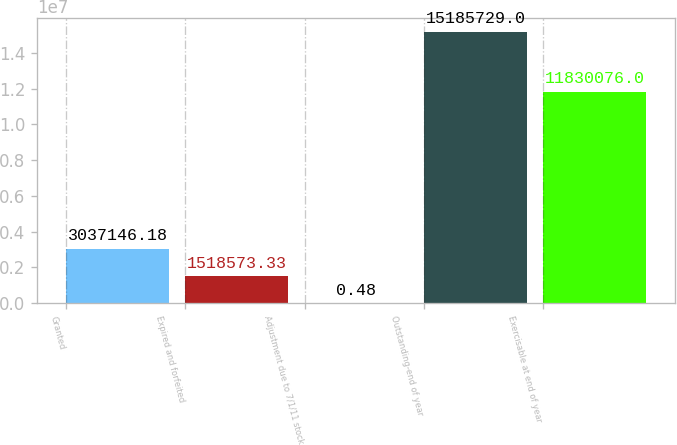<chart> <loc_0><loc_0><loc_500><loc_500><bar_chart><fcel>Granted<fcel>Expired and forfeited<fcel>Adjustment due to 7/1/11 stock<fcel>Outstanding-end of year<fcel>Exercisable at end of year<nl><fcel>3.03715e+06<fcel>1.51857e+06<fcel>0.48<fcel>1.51857e+07<fcel>1.18301e+07<nl></chart> 